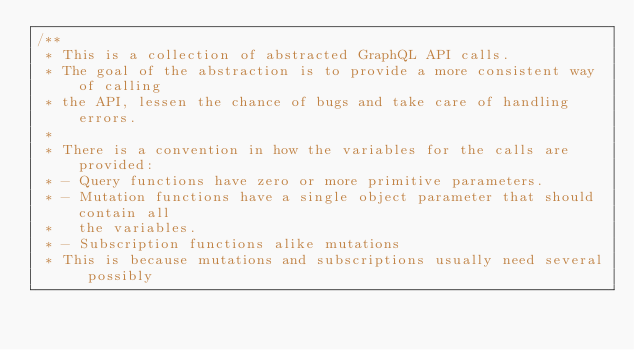<code> <loc_0><loc_0><loc_500><loc_500><_JavaScript_>/**
 * This is a collection of abstracted GraphQL API calls.
 * The goal of the abstraction is to provide a more consistent way of calling
 * the API, lessen the chance of bugs and take care of handling errors.
 *
 * There is a convention in how the variables for the calls are provided:
 * - Query functions have zero or more primitive parameters.
 * - Mutation functions have a single object parameter that should contain all
 *   the variables.
 * - Subscription functions alike mutations
 * This is because mutations and subscriptions usually need several possibly</code> 